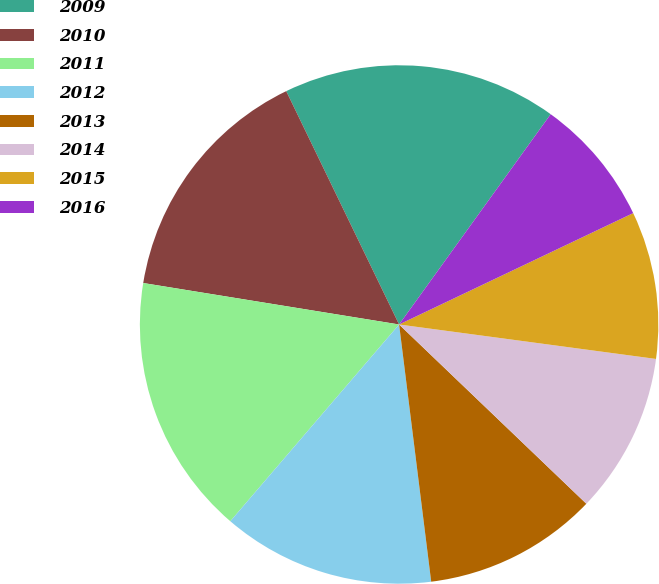Convert chart. <chart><loc_0><loc_0><loc_500><loc_500><pie_chart><fcel>2009<fcel>2010<fcel>2011<fcel>2012<fcel>2013<fcel>2014<fcel>2015<fcel>2016<nl><fcel>17.11%<fcel>15.27%<fcel>16.27%<fcel>13.26%<fcel>10.87%<fcel>10.03%<fcel>9.19%<fcel>7.99%<nl></chart> 